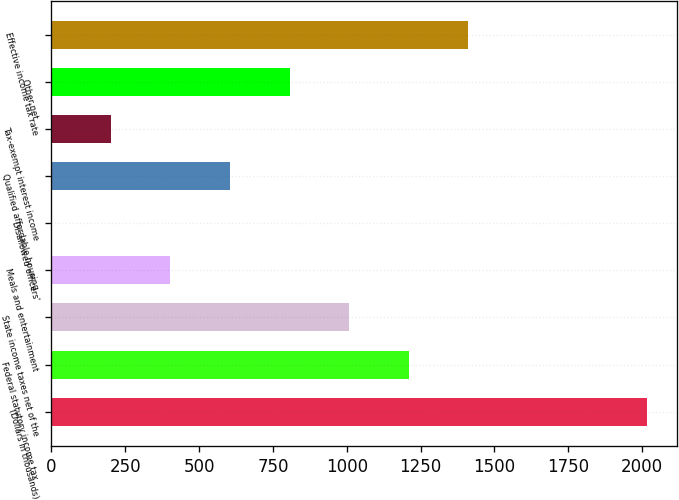Convert chart to OTSL. <chart><loc_0><loc_0><loc_500><loc_500><bar_chart><fcel>(Dollars in thousands)<fcel>Federal statutory income tax<fcel>State income taxes net of the<fcel>Meals and entertainment<fcel>Disallowed officers'<fcel>Qualified affordable housing<fcel>Tax-exempt interest income<fcel>Other net<fcel>Effective income tax rate<nl><fcel>2016<fcel>1209.64<fcel>1008.05<fcel>403.28<fcel>0.1<fcel>604.87<fcel>201.69<fcel>806.46<fcel>1411.23<nl></chart> 